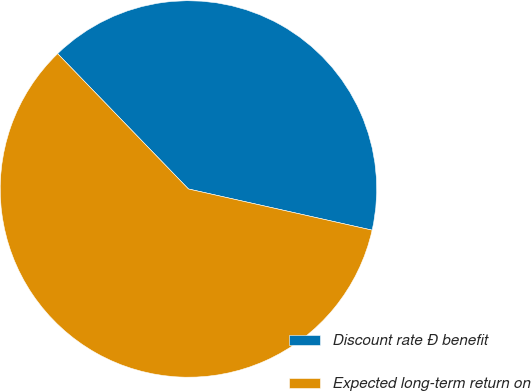Convert chart. <chart><loc_0><loc_0><loc_500><loc_500><pie_chart><fcel>Discount rate Ð benefit<fcel>Expected long-term return on<nl><fcel>40.74%<fcel>59.26%<nl></chart> 